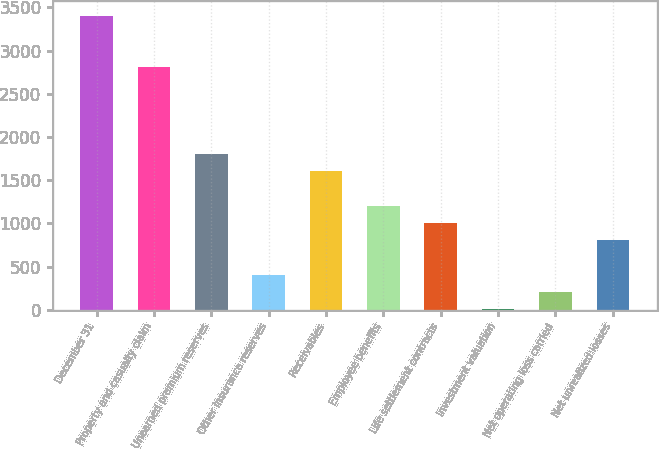Convert chart. <chart><loc_0><loc_0><loc_500><loc_500><bar_chart><fcel>December 31<fcel>Property and casualty claim<fcel>Unearned premium reserves<fcel>Other insurance reserves<fcel>Receivables<fcel>Employee benefits<fcel>Life settlement contracts<fcel>Investment valuation<fcel>Net operating loss carried<fcel>Net unrealized losses<nl><fcel>3406.3<fcel>2806.6<fcel>1807.1<fcel>407.8<fcel>1607.2<fcel>1207.4<fcel>1007.5<fcel>8<fcel>207.9<fcel>807.6<nl></chart> 